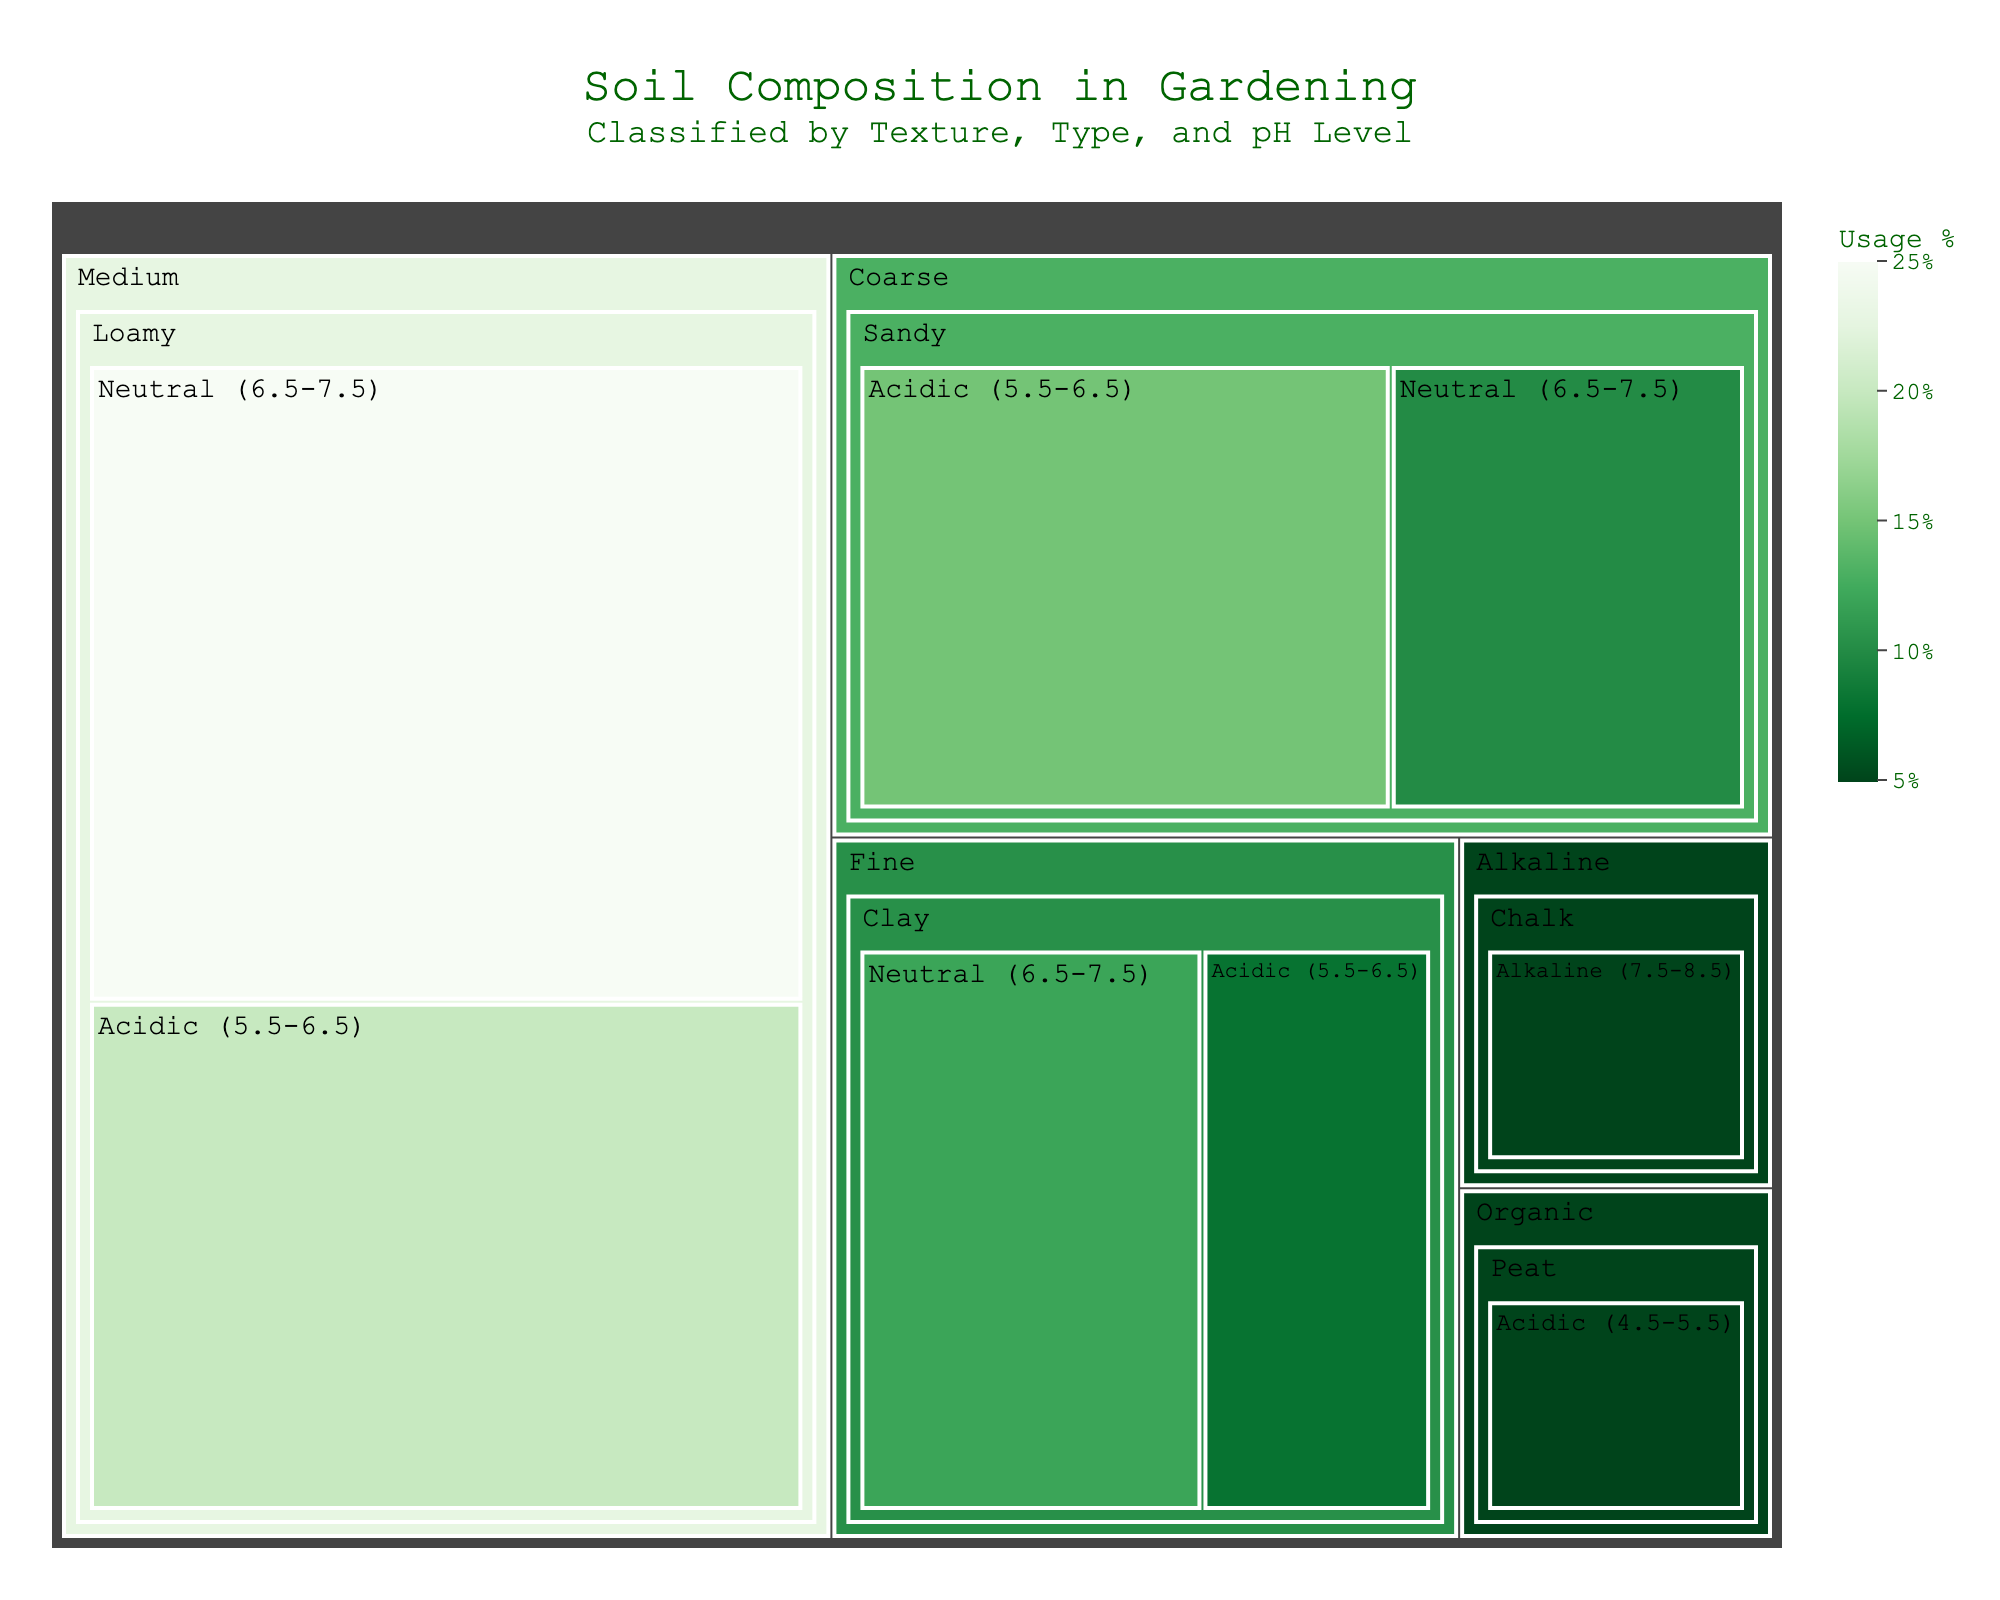what is the title of the figure? The title is provided at the top of the treemap. The title reads "Soil Composition in Gardening" with a subtitle "<br>Classified by Texture, Type, and pH Level</sub>". This explains the main subject of the data displayed in the treemap.
Answer: Soil Composition in Gardening Which type of soil has the highest usage percentage in Neutral pH level? By looking at the treemap, identify the soil type with the largest area under the Neutral (6.5-7.5) pH category. The largest section is for Loamy soil in the Neutral pH, indicating it has the highest usage percentage.
Answer: Loamy What is the total usage percentage of soils with Coarse texture? Locate all soil types under the Coarse texture category. Sum their usage percentages: Sandy (Acidic) – 15% and Sandy (Neutral) – 10%. 15 + 10 = 25%.
Answer: 25% Which soil type has a usage percentage of 5%? Look at the treemap and find the areas with a value of 5%. There are two soil types: Peat in Acidic and Chalk in Alkaline categories, with each having a 5% usage percentage. These correspond to the two labels indicating usage percentages within the treemap.
Answer: Peat and Chalk Which texture has the most diverse pH levels represented? Identify the textures that have segments in both Acidic and Neutral or Alkaline categories. Both Medium and Fine textures have soils in the Acidic and Neutral categories, while Organic and Alkaline textures only have one pH level.
Answer: Medium and Fine What is the difference in usage percentage between Loamy and Clay soils in Neutral pH level? Compare the usage percentages of Loamy and Clay soils under the Neutral (6.5-7.5) pH level. Loamy soil has 25%, and Clay soil has 12%. The difference is calculated as 25 - 12 = 13%.
Answer: 13% In which pH level do Coarse textured soils have a higher usage percentage, Acidic or Neutral? Compare the usage percentages of Coarse textured soils under the Acidic and Neutral categories. Acidic has 15%, and Neutral has 10%. 15 > 10, so the Coarse textured soil has a higher usage percentage in the Acidic category.
Answer: Acidic How does the usage percentage of Loamy, Neutral soil compare to all other soils combined? First, calculate the total usage percentage of all other soils combined. Add up all usage percentages from soils that are not Loamy, Neutral. Total = 100 - 25 = 75%. Loamy, Neutral soil has 25%, which is less than the combined total of all other soils (75%).
Answer: Less 